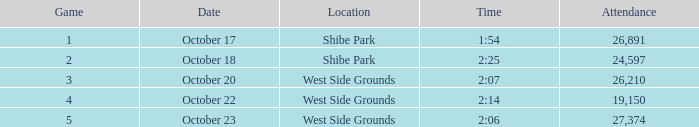For the game that was played on october 22 in west side grounds, what is the total attendance 1.0. I'm looking to parse the entire table for insights. Could you assist me with that? {'header': ['Game', 'Date', 'Location', 'Time', 'Attendance'], 'rows': [['1', 'October 17', 'Shibe Park', '1:54', '26,891'], ['2', 'October 18', 'Shibe Park', '2:25', '24,597'], ['3', 'October 20', 'West Side Grounds', '2:07', '26,210'], ['4', 'October 22', 'West Side Grounds', '2:14', '19,150'], ['5', 'October 23', 'West Side Grounds', '2:06', '27,374']]} 